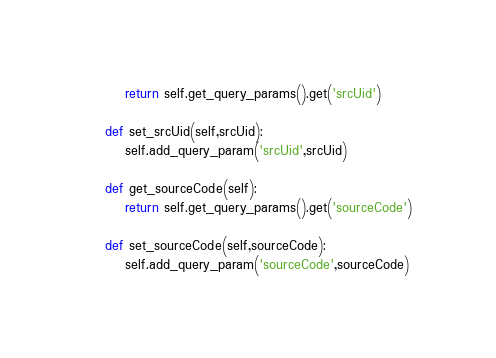Convert code to text. <code><loc_0><loc_0><loc_500><loc_500><_Python_>		return self.get_query_params().get('srcUid')

	def set_srcUid(self,srcUid):
		self.add_query_param('srcUid',srcUid)

	def get_sourceCode(self):
		return self.get_query_params().get('sourceCode')

	def set_sourceCode(self,sourceCode):
		self.add_query_param('sourceCode',sourceCode)</code> 